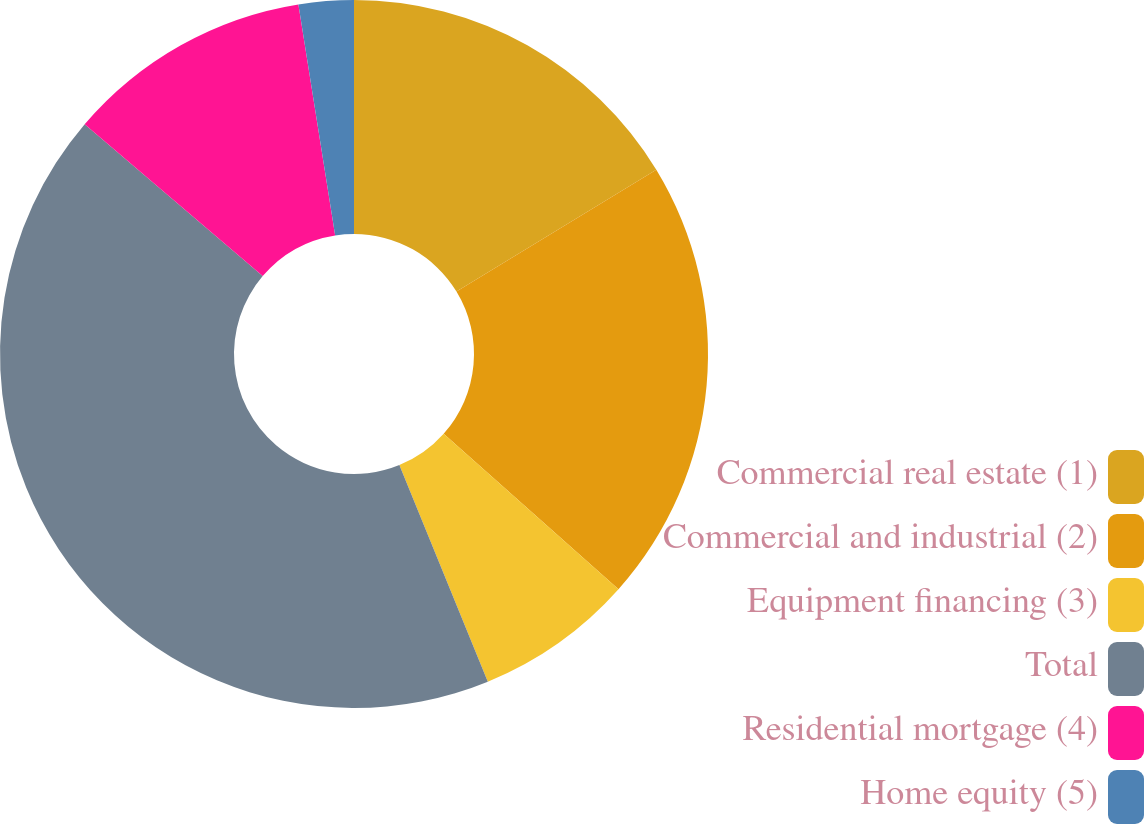Convert chart to OTSL. <chart><loc_0><loc_0><loc_500><loc_500><pie_chart><fcel>Commercial real estate (1)<fcel>Commercial and industrial (2)<fcel>Equipment financing (3)<fcel>Total<fcel>Residential mortgage (4)<fcel>Home equity (5)<nl><fcel>16.29%<fcel>20.28%<fcel>7.26%<fcel>42.41%<fcel>11.25%<fcel>2.51%<nl></chart> 